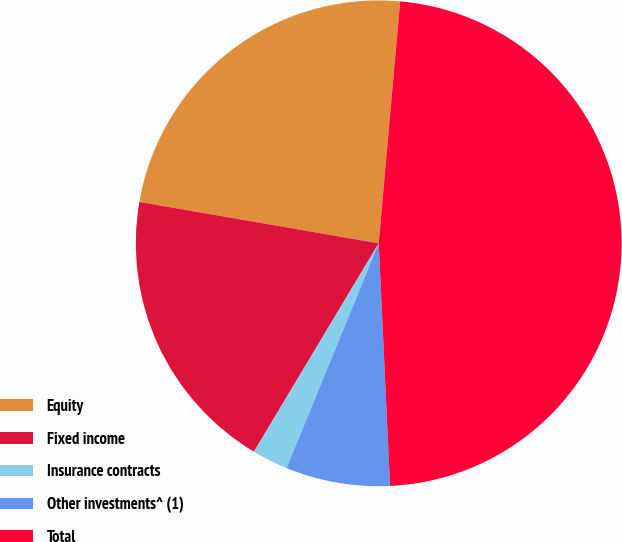Convert chart. <chart><loc_0><loc_0><loc_500><loc_500><pie_chart><fcel>Equity<fcel>Fixed income<fcel>Insurance contracts<fcel>Other investments^ (1)<fcel>Total<nl><fcel>23.68%<fcel>19.14%<fcel>2.39%<fcel>6.94%<fcel>47.85%<nl></chart> 